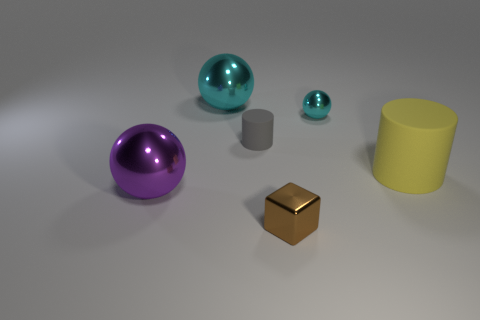Is the number of small cyan objects that are to the right of the metal cube greater than the number of cylinders?
Provide a short and direct response. No. Is the color of the tiny shiny thing that is behind the small brown metallic cube the same as the cube?
Provide a succinct answer. No. Is there anything else that is the same color as the tiny matte cylinder?
Ensure brevity in your answer.  No. What color is the large metal thing that is in front of the big object that is on the right side of the small cyan metallic sphere that is to the right of the small brown metallic block?
Give a very brief answer. Purple. Does the brown metal cube have the same size as the purple metal sphere?
Your response must be concise. No. How many purple balls have the same size as the yellow thing?
Ensure brevity in your answer.  1. There is a metal object that is the same color as the small sphere; what shape is it?
Your answer should be compact. Sphere. Are the ball in front of the small rubber cylinder and the cylinder behind the big cylinder made of the same material?
Ensure brevity in your answer.  No. Is there anything else that is the same shape as the tiny gray thing?
Provide a short and direct response. Yes. The small cylinder is what color?
Keep it short and to the point. Gray. 